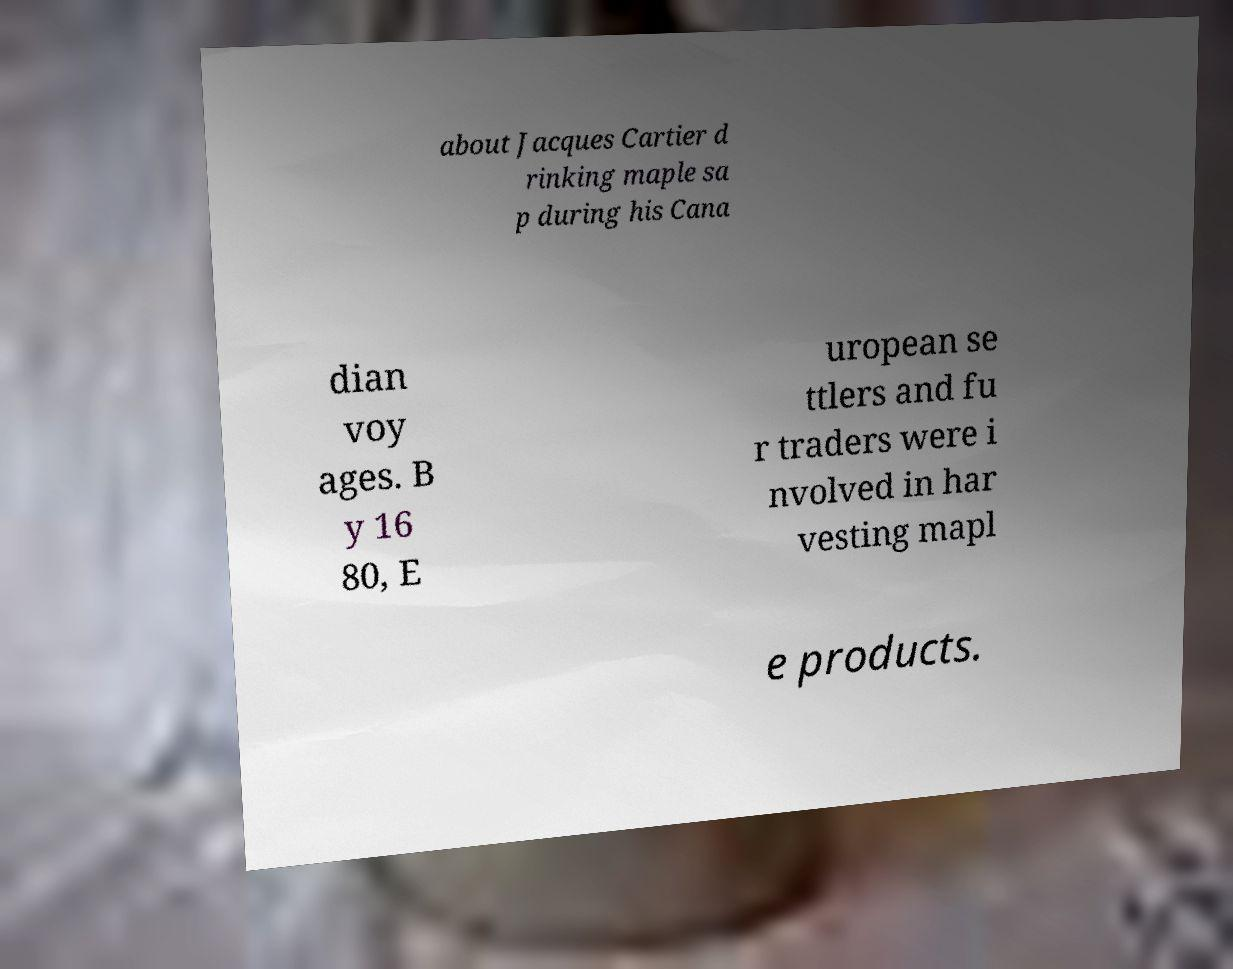There's text embedded in this image that I need extracted. Can you transcribe it verbatim? about Jacques Cartier d rinking maple sa p during his Cana dian voy ages. B y 16 80, E uropean se ttlers and fu r traders were i nvolved in har vesting mapl e products. 